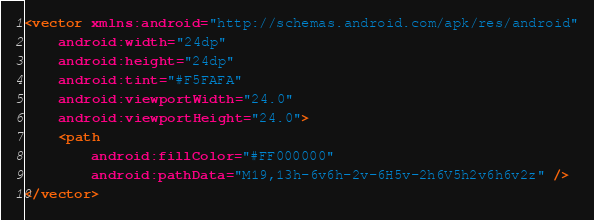<code> <loc_0><loc_0><loc_500><loc_500><_XML_><vector xmlns:android="http://schemas.android.com/apk/res/android"
    android:width="24dp"
    android:height="24dp"
    android:tint="#F5FAFA"
    android:viewportWidth="24.0"
    android:viewportHeight="24.0">
    <path
        android:fillColor="#FF000000"
        android:pathData="M19,13h-6v6h-2v-6H5v-2h6V5h2v6h6v2z" />
</vector>
</code> 